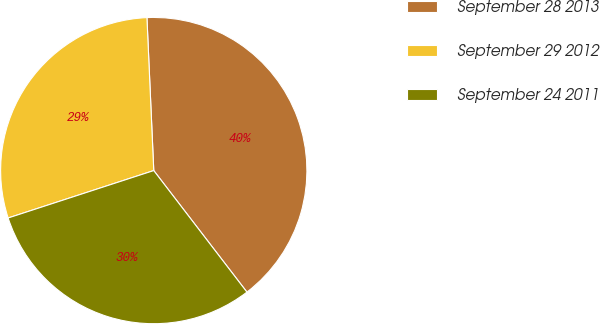Convert chart to OTSL. <chart><loc_0><loc_0><loc_500><loc_500><pie_chart><fcel>September 28 2013<fcel>September 29 2012<fcel>September 24 2011<nl><fcel>40.3%<fcel>29.3%<fcel>30.4%<nl></chart> 